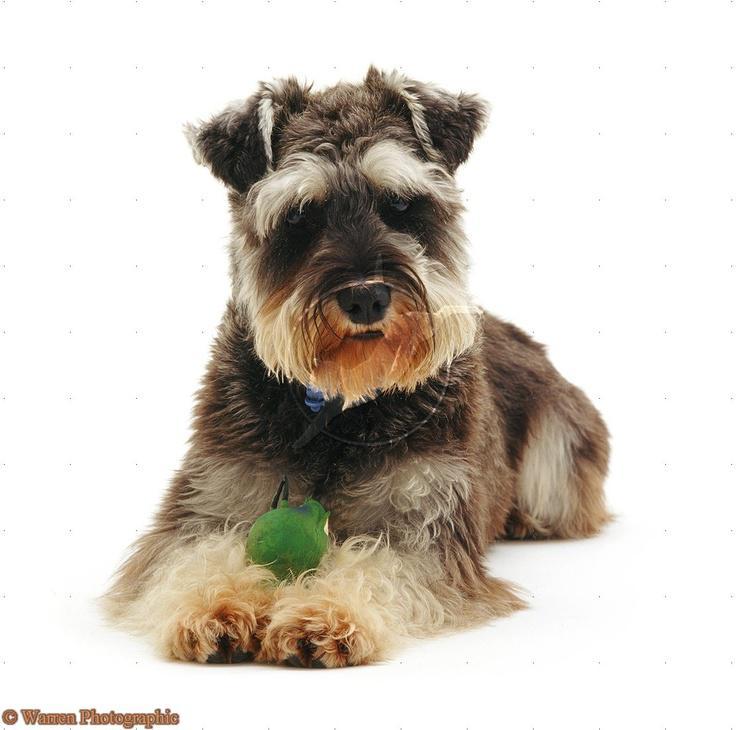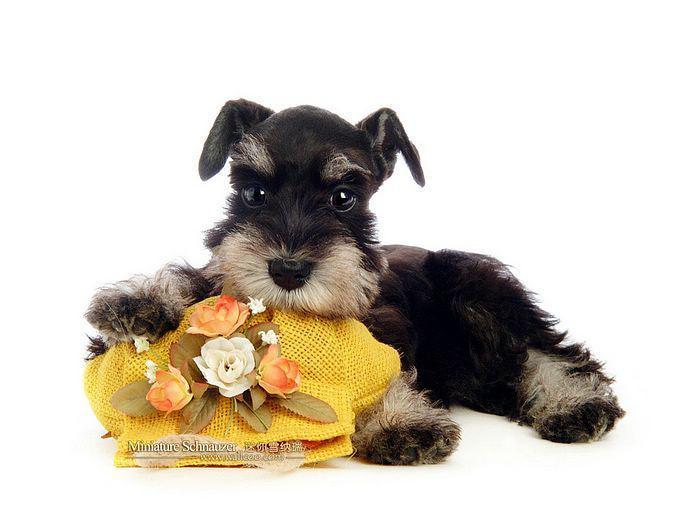The first image is the image on the left, the second image is the image on the right. Analyze the images presented: Is the assertion "There is at least one dog completely surrounded by whiteness with no shadows of its tail." valid? Answer yes or no. Yes. 